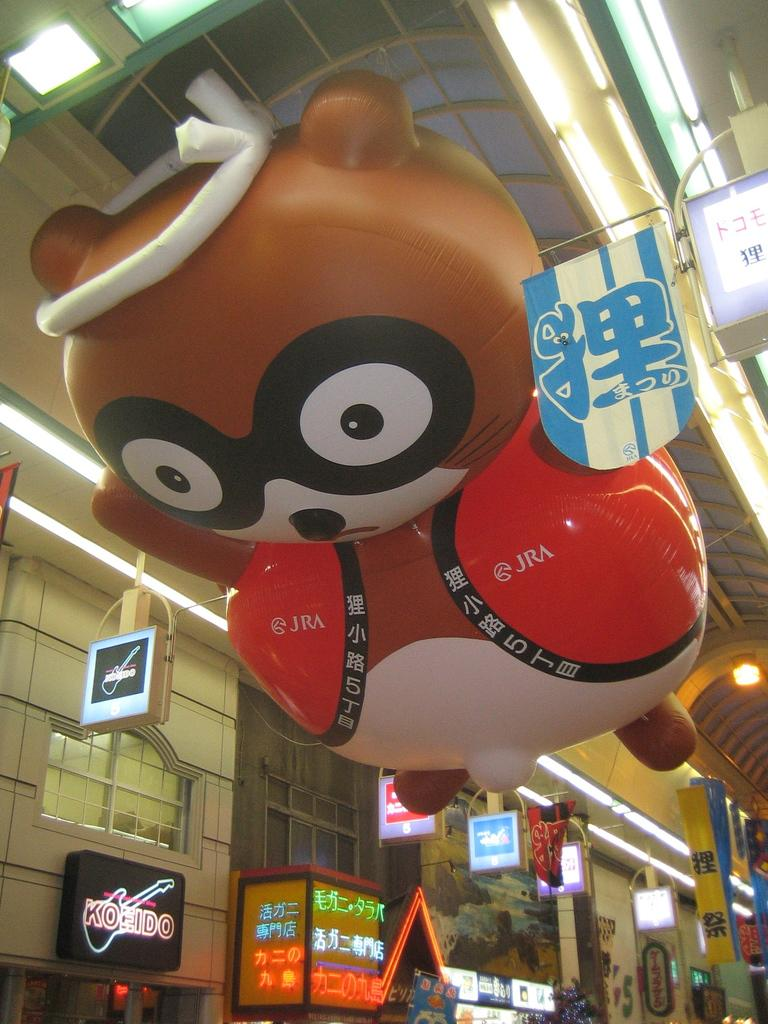What type of objects can be seen in the image? There are boards and a balloon toy in the image. What type of structure is visible in the image? There is a wall in the image. What architectural feature is present in the wall? There are windows in the image. Are there any other objects present in the image besides the boards, balloon toy, wall, and windows? Yes, there are other objects present in the image. What type of gold jewelry is the person wearing in the image? There is no person or gold jewelry present in the image. How many kisses can be seen on the balloon toy in the image? The balloon toy does not have any kisses; it is a toy and not a person. 